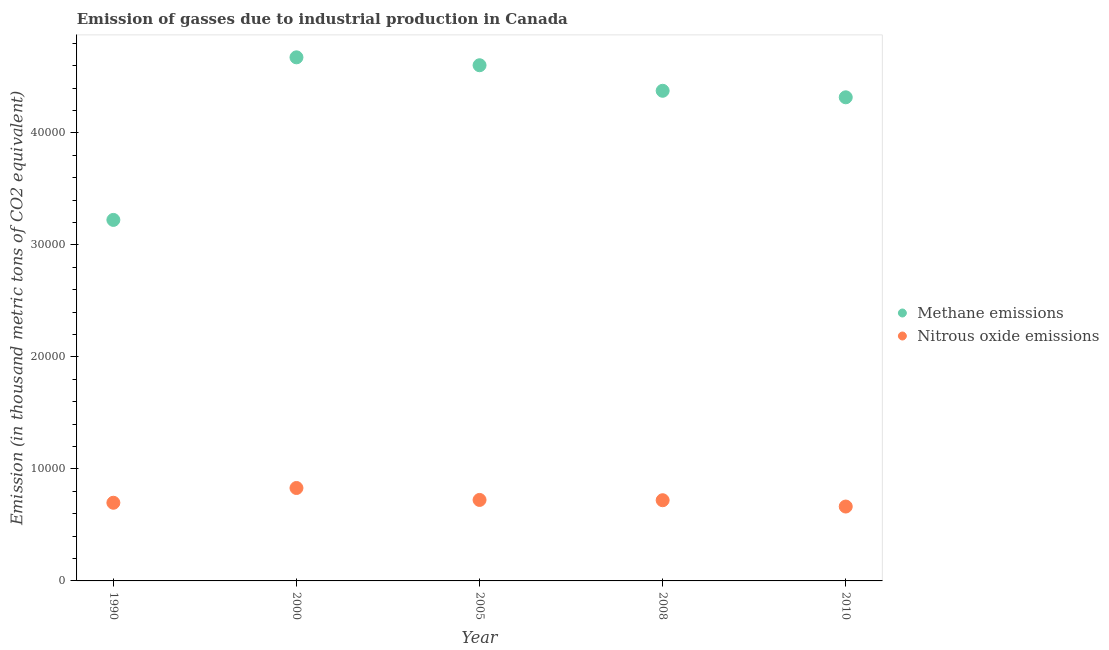How many different coloured dotlines are there?
Offer a very short reply. 2. Is the number of dotlines equal to the number of legend labels?
Keep it short and to the point. Yes. What is the amount of methane emissions in 2000?
Provide a short and direct response. 4.68e+04. Across all years, what is the maximum amount of methane emissions?
Provide a short and direct response. 4.68e+04. Across all years, what is the minimum amount of nitrous oxide emissions?
Offer a very short reply. 6641.9. In which year was the amount of methane emissions minimum?
Keep it short and to the point. 1990. What is the total amount of methane emissions in the graph?
Give a very brief answer. 2.12e+05. What is the difference between the amount of methane emissions in 2005 and that in 2008?
Keep it short and to the point. 2281.2. What is the difference between the amount of nitrous oxide emissions in 1990 and the amount of methane emissions in 2000?
Offer a terse response. -3.98e+04. What is the average amount of nitrous oxide emissions per year?
Make the answer very short. 7271.08. In the year 2000, what is the difference between the amount of nitrous oxide emissions and amount of methane emissions?
Your answer should be compact. -3.85e+04. What is the ratio of the amount of nitrous oxide emissions in 1990 to that in 2008?
Make the answer very short. 0.97. What is the difference between the highest and the second highest amount of nitrous oxide emissions?
Provide a short and direct response. 1065.8. What is the difference between the highest and the lowest amount of methane emissions?
Ensure brevity in your answer.  1.45e+04. Is the sum of the amount of methane emissions in 2000 and 2008 greater than the maximum amount of nitrous oxide emissions across all years?
Make the answer very short. Yes. Is the amount of methane emissions strictly greater than the amount of nitrous oxide emissions over the years?
Your answer should be very brief. Yes. How many dotlines are there?
Provide a short and direct response. 2. Are the values on the major ticks of Y-axis written in scientific E-notation?
Give a very brief answer. No. Does the graph contain any zero values?
Offer a very short reply. No. What is the title of the graph?
Provide a short and direct response. Emission of gasses due to industrial production in Canada. Does "Ages 15-24" appear as one of the legend labels in the graph?
Provide a short and direct response. No. What is the label or title of the Y-axis?
Offer a very short reply. Emission (in thousand metric tons of CO2 equivalent). What is the Emission (in thousand metric tons of CO2 equivalent) in Methane emissions in 1990?
Keep it short and to the point. 3.22e+04. What is the Emission (in thousand metric tons of CO2 equivalent) of Nitrous oxide emissions in 1990?
Your answer should be compact. 6979.7. What is the Emission (in thousand metric tons of CO2 equivalent) of Methane emissions in 2000?
Your answer should be compact. 4.68e+04. What is the Emission (in thousand metric tons of CO2 equivalent) of Nitrous oxide emissions in 2000?
Offer a terse response. 8297.1. What is the Emission (in thousand metric tons of CO2 equivalent) in Methane emissions in 2005?
Your response must be concise. 4.60e+04. What is the Emission (in thousand metric tons of CO2 equivalent) in Nitrous oxide emissions in 2005?
Offer a very short reply. 7231.3. What is the Emission (in thousand metric tons of CO2 equivalent) of Methane emissions in 2008?
Offer a terse response. 4.38e+04. What is the Emission (in thousand metric tons of CO2 equivalent) in Nitrous oxide emissions in 2008?
Give a very brief answer. 7205.4. What is the Emission (in thousand metric tons of CO2 equivalent) in Methane emissions in 2010?
Your answer should be very brief. 4.32e+04. What is the Emission (in thousand metric tons of CO2 equivalent) of Nitrous oxide emissions in 2010?
Ensure brevity in your answer.  6641.9. Across all years, what is the maximum Emission (in thousand metric tons of CO2 equivalent) in Methane emissions?
Your response must be concise. 4.68e+04. Across all years, what is the maximum Emission (in thousand metric tons of CO2 equivalent) of Nitrous oxide emissions?
Provide a short and direct response. 8297.1. Across all years, what is the minimum Emission (in thousand metric tons of CO2 equivalent) of Methane emissions?
Your answer should be very brief. 3.22e+04. Across all years, what is the minimum Emission (in thousand metric tons of CO2 equivalent) of Nitrous oxide emissions?
Your answer should be compact. 6641.9. What is the total Emission (in thousand metric tons of CO2 equivalent) in Methane emissions in the graph?
Ensure brevity in your answer.  2.12e+05. What is the total Emission (in thousand metric tons of CO2 equivalent) of Nitrous oxide emissions in the graph?
Your answer should be very brief. 3.64e+04. What is the difference between the Emission (in thousand metric tons of CO2 equivalent) of Methane emissions in 1990 and that in 2000?
Offer a terse response. -1.45e+04. What is the difference between the Emission (in thousand metric tons of CO2 equivalent) of Nitrous oxide emissions in 1990 and that in 2000?
Offer a terse response. -1317.4. What is the difference between the Emission (in thousand metric tons of CO2 equivalent) in Methane emissions in 1990 and that in 2005?
Keep it short and to the point. -1.38e+04. What is the difference between the Emission (in thousand metric tons of CO2 equivalent) in Nitrous oxide emissions in 1990 and that in 2005?
Make the answer very short. -251.6. What is the difference between the Emission (in thousand metric tons of CO2 equivalent) in Methane emissions in 1990 and that in 2008?
Make the answer very short. -1.15e+04. What is the difference between the Emission (in thousand metric tons of CO2 equivalent) in Nitrous oxide emissions in 1990 and that in 2008?
Offer a terse response. -225.7. What is the difference between the Emission (in thousand metric tons of CO2 equivalent) of Methane emissions in 1990 and that in 2010?
Your answer should be very brief. -1.09e+04. What is the difference between the Emission (in thousand metric tons of CO2 equivalent) in Nitrous oxide emissions in 1990 and that in 2010?
Make the answer very short. 337.8. What is the difference between the Emission (in thousand metric tons of CO2 equivalent) in Methane emissions in 2000 and that in 2005?
Ensure brevity in your answer.  705.9. What is the difference between the Emission (in thousand metric tons of CO2 equivalent) in Nitrous oxide emissions in 2000 and that in 2005?
Offer a very short reply. 1065.8. What is the difference between the Emission (in thousand metric tons of CO2 equivalent) in Methane emissions in 2000 and that in 2008?
Offer a very short reply. 2987.1. What is the difference between the Emission (in thousand metric tons of CO2 equivalent) of Nitrous oxide emissions in 2000 and that in 2008?
Your answer should be compact. 1091.7. What is the difference between the Emission (in thousand metric tons of CO2 equivalent) of Methane emissions in 2000 and that in 2010?
Make the answer very short. 3569.2. What is the difference between the Emission (in thousand metric tons of CO2 equivalent) of Nitrous oxide emissions in 2000 and that in 2010?
Ensure brevity in your answer.  1655.2. What is the difference between the Emission (in thousand metric tons of CO2 equivalent) of Methane emissions in 2005 and that in 2008?
Offer a terse response. 2281.2. What is the difference between the Emission (in thousand metric tons of CO2 equivalent) in Nitrous oxide emissions in 2005 and that in 2008?
Ensure brevity in your answer.  25.9. What is the difference between the Emission (in thousand metric tons of CO2 equivalent) of Methane emissions in 2005 and that in 2010?
Your answer should be compact. 2863.3. What is the difference between the Emission (in thousand metric tons of CO2 equivalent) of Nitrous oxide emissions in 2005 and that in 2010?
Your response must be concise. 589.4. What is the difference between the Emission (in thousand metric tons of CO2 equivalent) in Methane emissions in 2008 and that in 2010?
Keep it short and to the point. 582.1. What is the difference between the Emission (in thousand metric tons of CO2 equivalent) in Nitrous oxide emissions in 2008 and that in 2010?
Ensure brevity in your answer.  563.5. What is the difference between the Emission (in thousand metric tons of CO2 equivalent) in Methane emissions in 1990 and the Emission (in thousand metric tons of CO2 equivalent) in Nitrous oxide emissions in 2000?
Make the answer very short. 2.39e+04. What is the difference between the Emission (in thousand metric tons of CO2 equivalent) of Methane emissions in 1990 and the Emission (in thousand metric tons of CO2 equivalent) of Nitrous oxide emissions in 2005?
Keep it short and to the point. 2.50e+04. What is the difference between the Emission (in thousand metric tons of CO2 equivalent) in Methane emissions in 1990 and the Emission (in thousand metric tons of CO2 equivalent) in Nitrous oxide emissions in 2008?
Provide a short and direct response. 2.50e+04. What is the difference between the Emission (in thousand metric tons of CO2 equivalent) of Methane emissions in 1990 and the Emission (in thousand metric tons of CO2 equivalent) of Nitrous oxide emissions in 2010?
Give a very brief answer. 2.56e+04. What is the difference between the Emission (in thousand metric tons of CO2 equivalent) in Methane emissions in 2000 and the Emission (in thousand metric tons of CO2 equivalent) in Nitrous oxide emissions in 2005?
Keep it short and to the point. 3.95e+04. What is the difference between the Emission (in thousand metric tons of CO2 equivalent) in Methane emissions in 2000 and the Emission (in thousand metric tons of CO2 equivalent) in Nitrous oxide emissions in 2008?
Offer a terse response. 3.95e+04. What is the difference between the Emission (in thousand metric tons of CO2 equivalent) of Methane emissions in 2000 and the Emission (in thousand metric tons of CO2 equivalent) of Nitrous oxide emissions in 2010?
Make the answer very short. 4.01e+04. What is the difference between the Emission (in thousand metric tons of CO2 equivalent) of Methane emissions in 2005 and the Emission (in thousand metric tons of CO2 equivalent) of Nitrous oxide emissions in 2008?
Give a very brief answer. 3.88e+04. What is the difference between the Emission (in thousand metric tons of CO2 equivalent) of Methane emissions in 2005 and the Emission (in thousand metric tons of CO2 equivalent) of Nitrous oxide emissions in 2010?
Your answer should be very brief. 3.94e+04. What is the difference between the Emission (in thousand metric tons of CO2 equivalent) in Methane emissions in 2008 and the Emission (in thousand metric tons of CO2 equivalent) in Nitrous oxide emissions in 2010?
Offer a very short reply. 3.71e+04. What is the average Emission (in thousand metric tons of CO2 equivalent) in Methane emissions per year?
Your answer should be very brief. 4.24e+04. What is the average Emission (in thousand metric tons of CO2 equivalent) in Nitrous oxide emissions per year?
Give a very brief answer. 7271.08. In the year 1990, what is the difference between the Emission (in thousand metric tons of CO2 equivalent) of Methane emissions and Emission (in thousand metric tons of CO2 equivalent) of Nitrous oxide emissions?
Your response must be concise. 2.53e+04. In the year 2000, what is the difference between the Emission (in thousand metric tons of CO2 equivalent) of Methane emissions and Emission (in thousand metric tons of CO2 equivalent) of Nitrous oxide emissions?
Provide a short and direct response. 3.85e+04. In the year 2005, what is the difference between the Emission (in thousand metric tons of CO2 equivalent) of Methane emissions and Emission (in thousand metric tons of CO2 equivalent) of Nitrous oxide emissions?
Offer a very short reply. 3.88e+04. In the year 2008, what is the difference between the Emission (in thousand metric tons of CO2 equivalent) of Methane emissions and Emission (in thousand metric tons of CO2 equivalent) of Nitrous oxide emissions?
Your answer should be very brief. 3.66e+04. In the year 2010, what is the difference between the Emission (in thousand metric tons of CO2 equivalent) of Methane emissions and Emission (in thousand metric tons of CO2 equivalent) of Nitrous oxide emissions?
Offer a terse response. 3.65e+04. What is the ratio of the Emission (in thousand metric tons of CO2 equivalent) in Methane emissions in 1990 to that in 2000?
Your answer should be compact. 0.69. What is the ratio of the Emission (in thousand metric tons of CO2 equivalent) of Nitrous oxide emissions in 1990 to that in 2000?
Give a very brief answer. 0.84. What is the ratio of the Emission (in thousand metric tons of CO2 equivalent) of Methane emissions in 1990 to that in 2005?
Give a very brief answer. 0.7. What is the ratio of the Emission (in thousand metric tons of CO2 equivalent) in Nitrous oxide emissions in 1990 to that in 2005?
Provide a short and direct response. 0.97. What is the ratio of the Emission (in thousand metric tons of CO2 equivalent) of Methane emissions in 1990 to that in 2008?
Offer a terse response. 0.74. What is the ratio of the Emission (in thousand metric tons of CO2 equivalent) in Nitrous oxide emissions in 1990 to that in 2008?
Your answer should be compact. 0.97. What is the ratio of the Emission (in thousand metric tons of CO2 equivalent) in Methane emissions in 1990 to that in 2010?
Your answer should be compact. 0.75. What is the ratio of the Emission (in thousand metric tons of CO2 equivalent) of Nitrous oxide emissions in 1990 to that in 2010?
Give a very brief answer. 1.05. What is the ratio of the Emission (in thousand metric tons of CO2 equivalent) in Methane emissions in 2000 to that in 2005?
Give a very brief answer. 1.02. What is the ratio of the Emission (in thousand metric tons of CO2 equivalent) in Nitrous oxide emissions in 2000 to that in 2005?
Your answer should be compact. 1.15. What is the ratio of the Emission (in thousand metric tons of CO2 equivalent) of Methane emissions in 2000 to that in 2008?
Provide a short and direct response. 1.07. What is the ratio of the Emission (in thousand metric tons of CO2 equivalent) of Nitrous oxide emissions in 2000 to that in 2008?
Provide a succinct answer. 1.15. What is the ratio of the Emission (in thousand metric tons of CO2 equivalent) of Methane emissions in 2000 to that in 2010?
Offer a terse response. 1.08. What is the ratio of the Emission (in thousand metric tons of CO2 equivalent) of Nitrous oxide emissions in 2000 to that in 2010?
Provide a short and direct response. 1.25. What is the ratio of the Emission (in thousand metric tons of CO2 equivalent) in Methane emissions in 2005 to that in 2008?
Offer a very short reply. 1.05. What is the ratio of the Emission (in thousand metric tons of CO2 equivalent) of Nitrous oxide emissions in 2005 to that in 2008?
Your answer should be compact. 1. What is the ratio of the Emission (in thousand metric tons of CO2 equivalent) in Methane emissions in 2005 to that in 2010?
Give a very brief answer. 1.07. What is the ratio of the Emission (in thousand metric tons of CO2 equivalent) of Nitrous oxide emissions in 2005 to that in 2010?
Make the answer very short. 1.09. What is the ratio of the Emission (in thousand metric tons of CO2 equivalent) of Methane emissions in 2008 to that in 2010?
Keep it short and to the point. 1.01. What is the ratio of the Emission (in thousand metric tons of CO2 equivalent) in Nitrous oxide emissions in 2008 to that in 2010?
Your response must be concise. 1.08. What is the difference between the highest and the second highest Emission (in thousand metric tons of CO2 equivalent) in Methane emissions?
Make the answer very short. 705.9. What is the difference between the highest and the second highest Emission (in thousand metric tons of CO2 equivalent) of Nitrous oxide emissions?
Make the answer very short. 1065.8. What is the difference between the highest and the lowest Emission (in thousand metric tons of CO2 equivalent) in Methane emissions?
Your answer should be compact. 1.45e+04. What is the difference between the highest and the lowest Emission (in thousand metric tons of CO2 equivalent) of Nitrous oxide emissions?
Provide a short and direct response. 1655.2. 